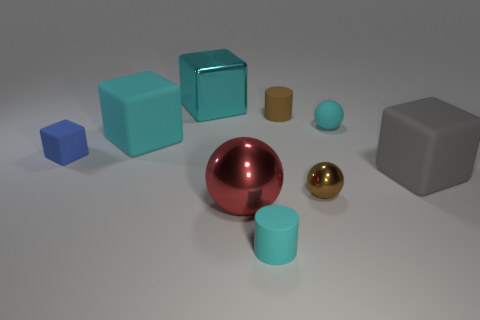Subtract all small balls. How many balls are left? 1 Subtract all purple balls. How many cyan cubes are left? 2 Subtract 1 balls. How many balls are left? 2 Subtract all gray blocks. How many blocks are left? 3 Subtract all balls. How many objects are left? 6 Subtract 1 cyan cylinders. How many objects are left? 8 Subtract all green cubes. Subtract all brown balls. How many cubes are left? 4 Subtract all big metallic blocks. Subtract all big blue rubber cylinders. How many objects are left? 8 Add 7 small metal objects. How many small metal objects are left? 8 Add 1 large gray rubber cylinders. How many large gray rubber cylinders exist? 1 